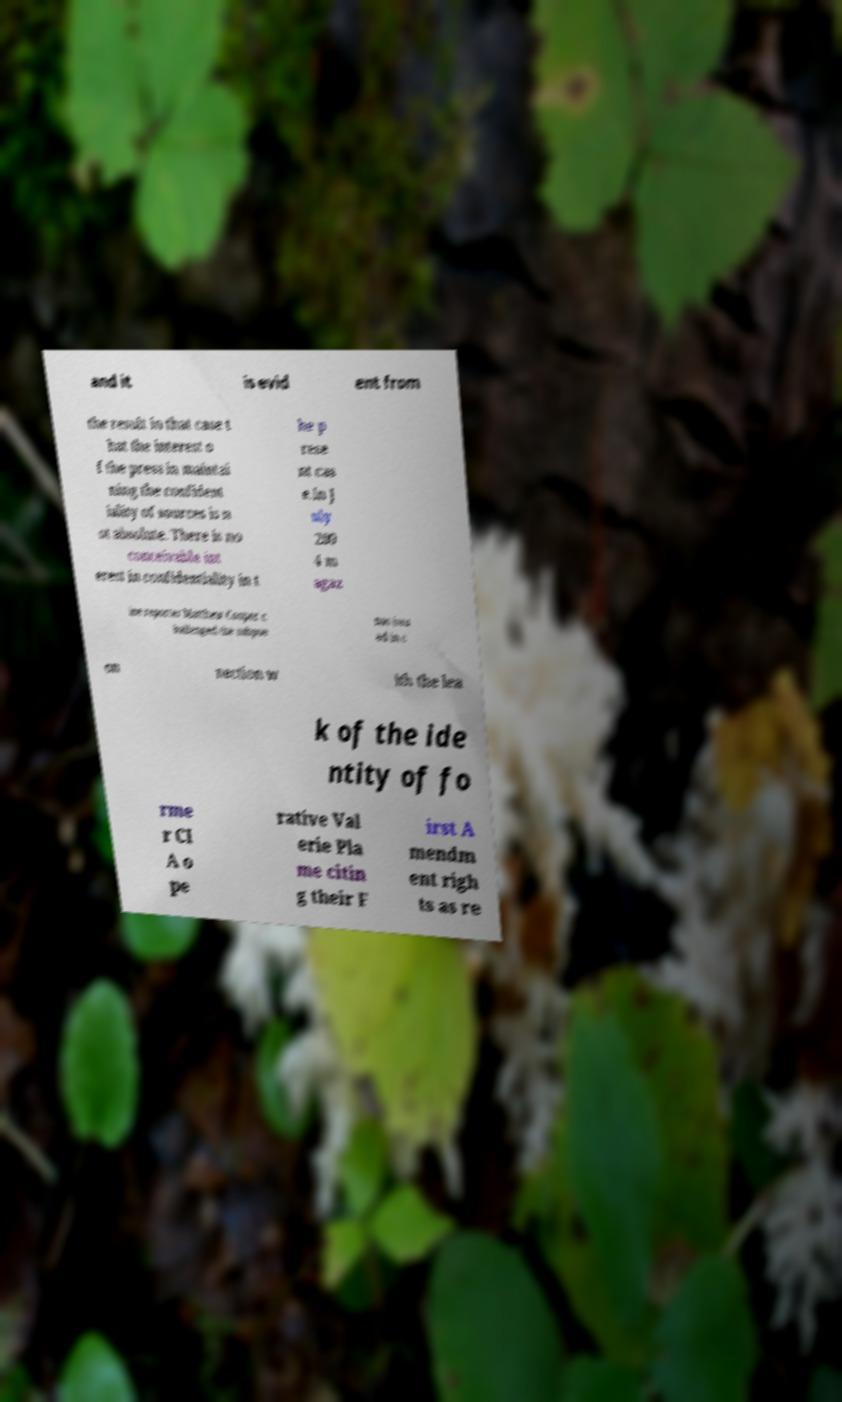I need the written content from this picture converted into text. Can you do that? and it is evid ent from the result in that case t hat the interest o f the press in maintai ning the confident iality of sources is n ot absolute. There is no conceivable int erest in confidentiality in t he p rese nt cas e.In J uly 200 4 m agaz ine reporter Matthew Cooper c hallenged the subpoe nas issu ed in c on nection w ith the lea k of the ide ntity of fo rme r CI A o pe rative Val erie Pla me citin g their F irst A mendm ent righ ts as re 